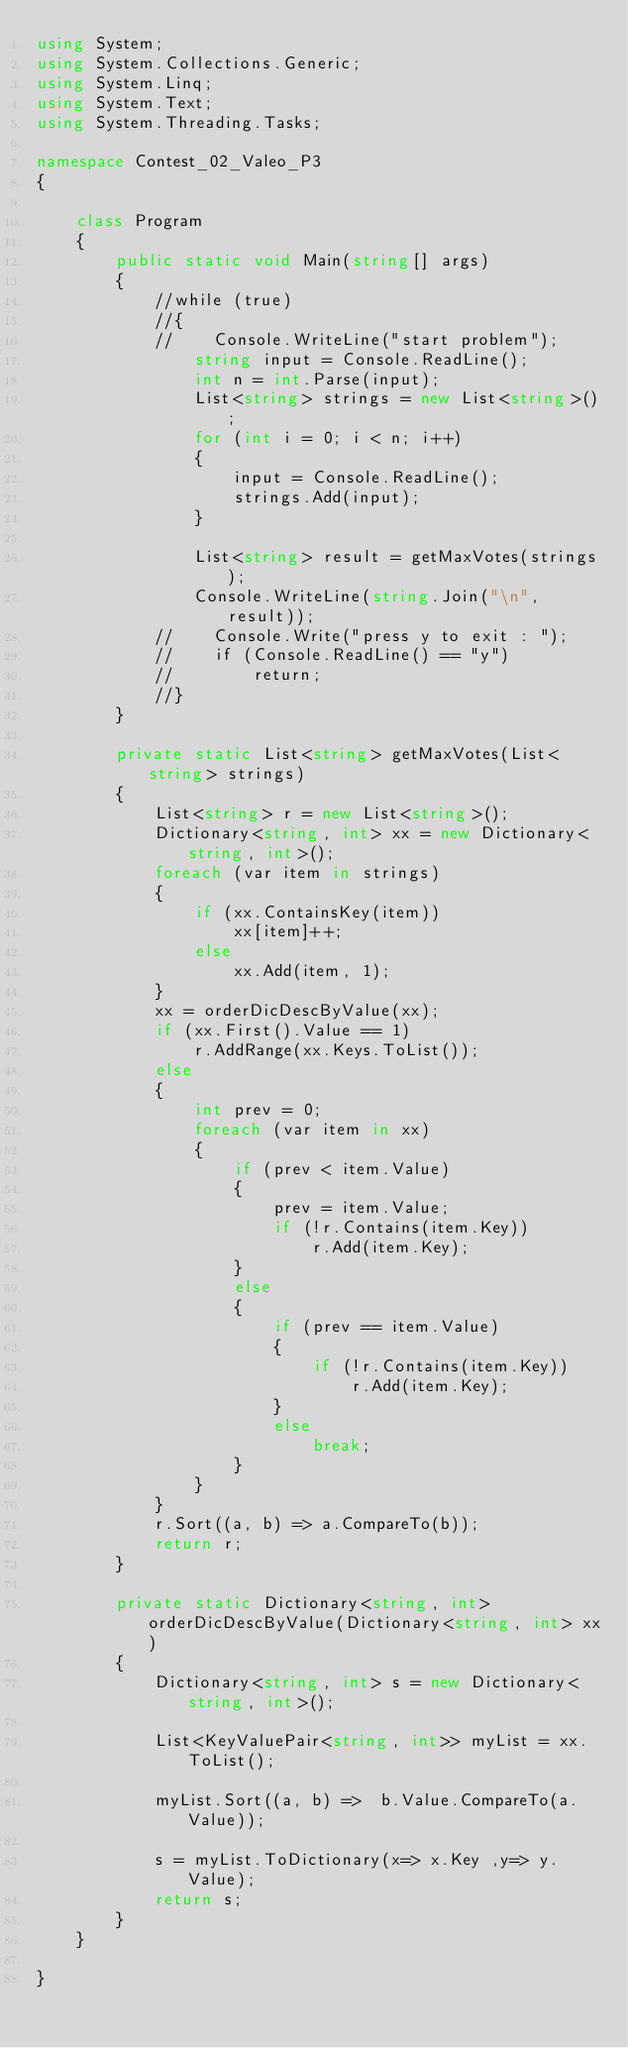<code> <loc_0><loc_0><loc_500><loc_500><_C#_>using System;
using System.Collections.Generic;
using System.Linq;
using System.Text;
using System.Threading.Tasks;

namespace Contest_02_Valeo_P3
{

    class Program
    {
        public static void Main(string[] args)
        {
            //while (true)
            //{
            //    Console.WriteLine("start problem");
                string input = Console.ReadLine();
                int n = int.Parse(input);
                List<string> strings = new List<string>();
                for (int i = 0; i < n; i++)
                {
                    input = Console.ReadLine();
                    strings.Add(input);
                }

                List<string> result = getMaxVotes(strings);
                Console.WriteLine(string.Join("\n", result));
            //    Console.Write("press y to exit : ");
            //    if (Console.ReadLine() == "y")
            //        return;
            //}
        }

        private static List<string> getMaxVotes(List<string> strings)
        {
            List<string> r = new List<string>();
            Dictionary<string, int> xx = new Dictionary<string, int>();
            foreach (var item in strings)
            {
                if (xx.ContainsKey(item))
                    xx[item]++;
                else
                    xx.Add(item, 1);
            }
            xx = orderDicDescByValue(xx);
            if (xx.First().Value == 1)
                r.AddRange(xx.Keys.ToList());
            else
            {
                int prev = 0;
                foreach (var item in xx)
                {
                    if (prev < item.Value)
                    {
                        prev = item.Value;
                        if (!r.Contains(item.Key))
                            r.Add(item.Key);
                    }
                    else
                    {
                        if (prev == item.Value)
                        {
                            if (!r.Contains(item.Key))
                                r.Add(item.Key);
                        }
                        else
                            break;
                    }
                }
            }
            r.Sort((a, b) => a.CompareTo(b));
            return r;
        }

        private static Dictionary<string, int> orderDicDescByValue(Dictionary<string, int> xx)
        {
            Dictionary<string, int> s = new Dictionary<string, int>();

            List<KeyValuePair<string, int>> myList = xx.ToList();

            myList.Sort((a, b) =>  b.Value.CompareTo(a.Value));

            s = myList.ToDictionary(x=> x.Key ,y=> y.Value);
            return s;
        }
    }
    
}
</code> 